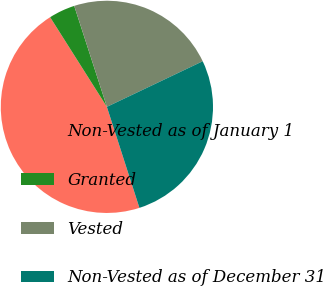<chart> <loc_0><loc_0><loc_500><loc_500><pie_chart><fcel>Non-Vested as of January 1<fcel>Granted<fcel>Vested<fcel>Non-Vested as of December 31<nl><fcel>45.98%<fcel>4.0%<fcel>22.91%<fcel>27.11%<nl></chart> 